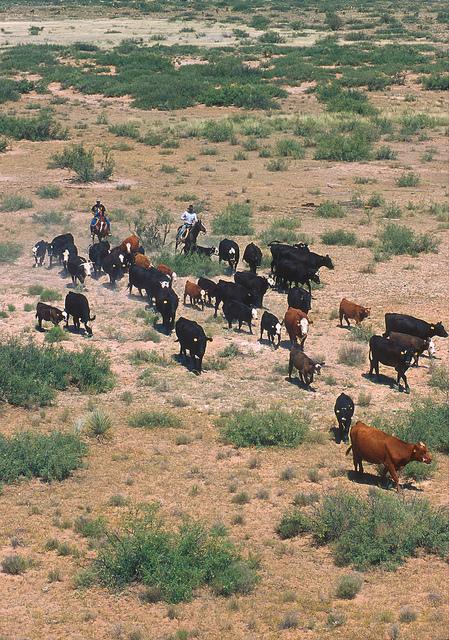Are the cows walking in junk?
Give a very brief answer. No. What color are the cows?
Be succinct. Black and brown. Are the cattle being herded?
Give a very brief answer. Yes. What color are the plants?
Answer briefly. Green. 